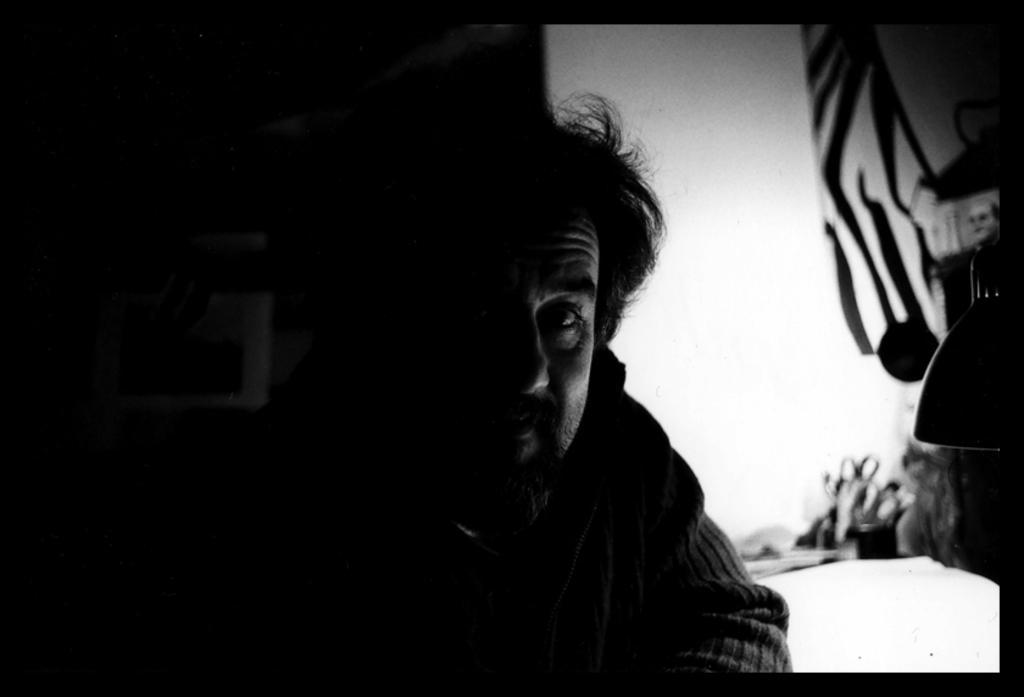Describe this image in one or two sentences. This picture is dark, there is a person. In the background it is blur. 